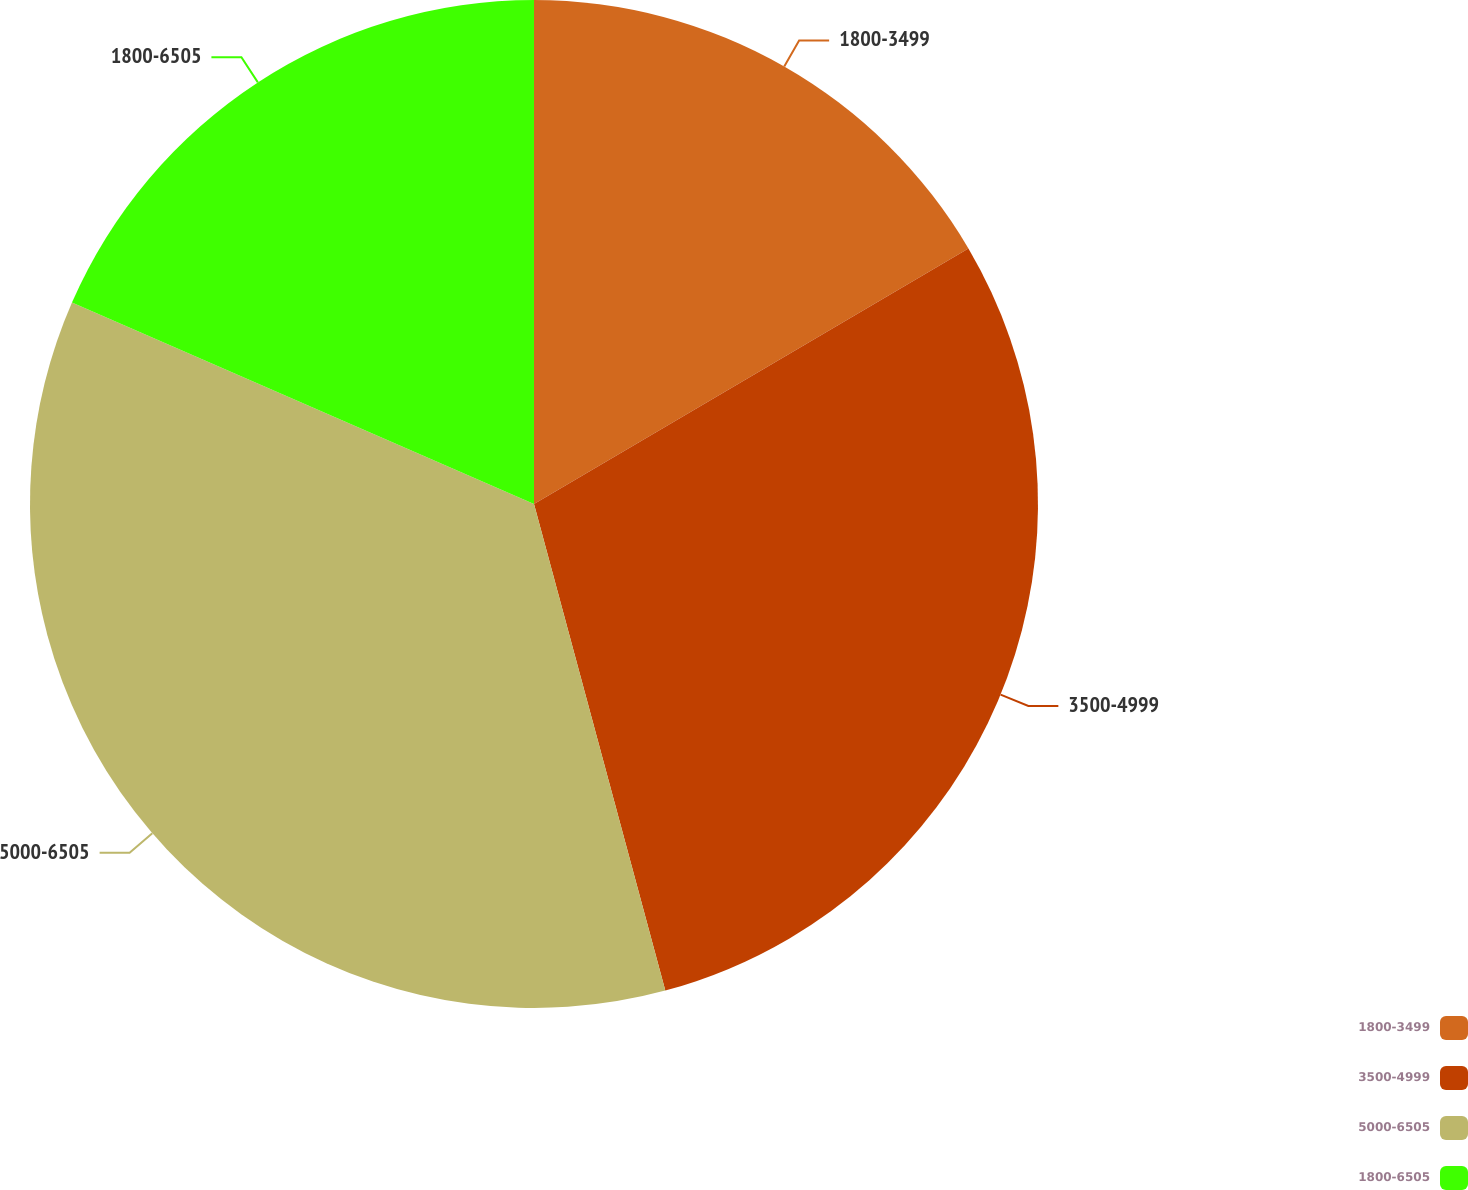<chart> <loc_0><loc_0><loc_500><loc_500><pie_chart><fcel>1800-3499<fcel>3500-4999<fcel>5000-6505<fcel>1800-6505<nl><fcel>16.54%<fcel>29.27%<fcel>35.74%<fcel>18.46%<nl></chart> 